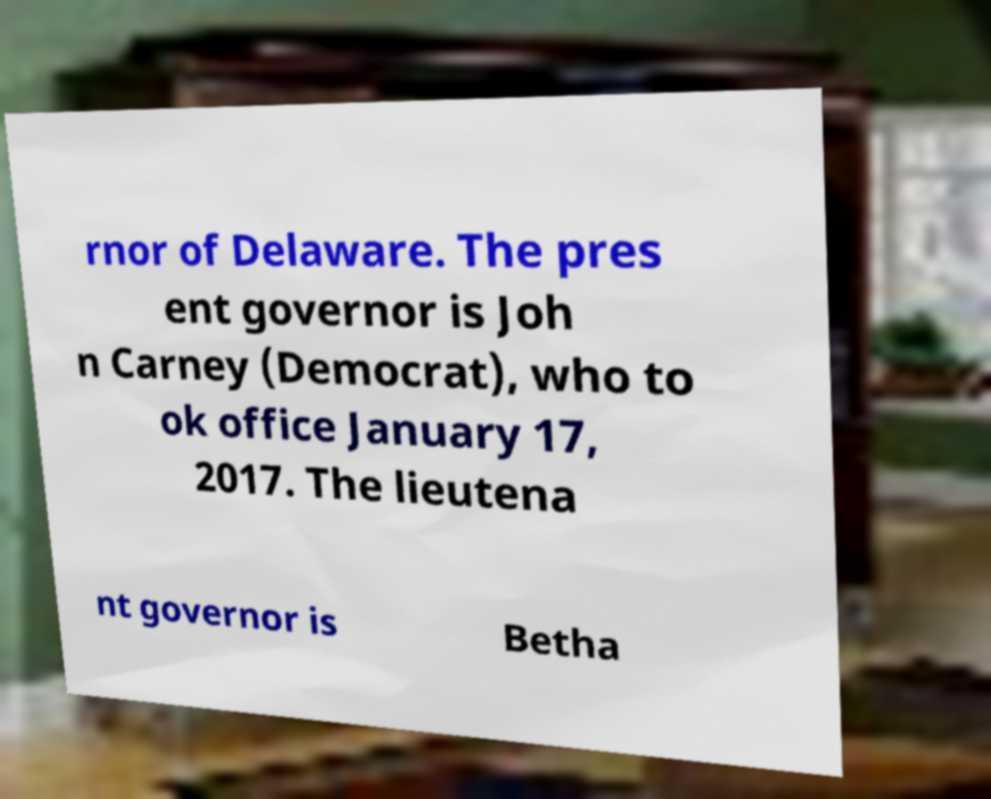I need the written content from this picture converted into text. Can you do that? rnor of Delaware. The pres ent governor is Joh n Carney (Democrat), who to ok office January 17, 2017. The lieutena nt governor is Betha 